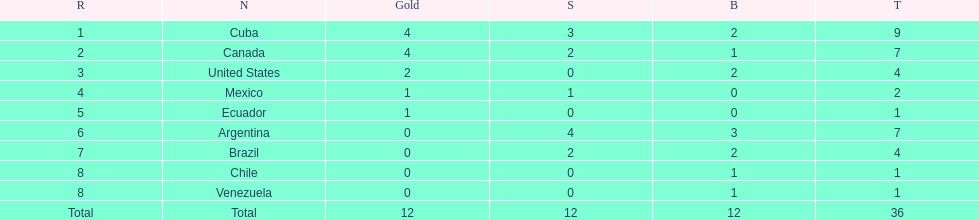Would you be able to parse every entry in this table? {'header': ['R', 'N', 'Gold', 'S', 'B', 'T'], 'rows': [['1', 'Cuba', '4', '3', '2', '9'], ['2', 'Canada', '4', '2', '1', '7'], ['3', 'United States', '2', '0', '2', '4'], ['4', 'Mexico', '1', '1', '0', '2'], ['5', 'Ecuador', '1', '0', '0', '1'], ['6', 'Argentina', '0', '4', '3', '7'], ['7', 'Brazil', '0', '2', '2', '4'], ['8', 'Chile', '0', '0', '1', '1'], ['8', 'Venezuela', '0', '0', '1', '1'], ['Total', 'Total', '12', '12', '12', '36']]} Who is currently ranked as the first place? Cuba. 